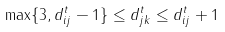Convert formula to latex. <formula><loc_0><loc_0><loc_500><loc_500>\max \{ 3 , d ^ { t } _ { i j } - 1 \} \leq d ^ { t } _ { j k } \leq d ^ { t } _ { i j } + 1</formula> 